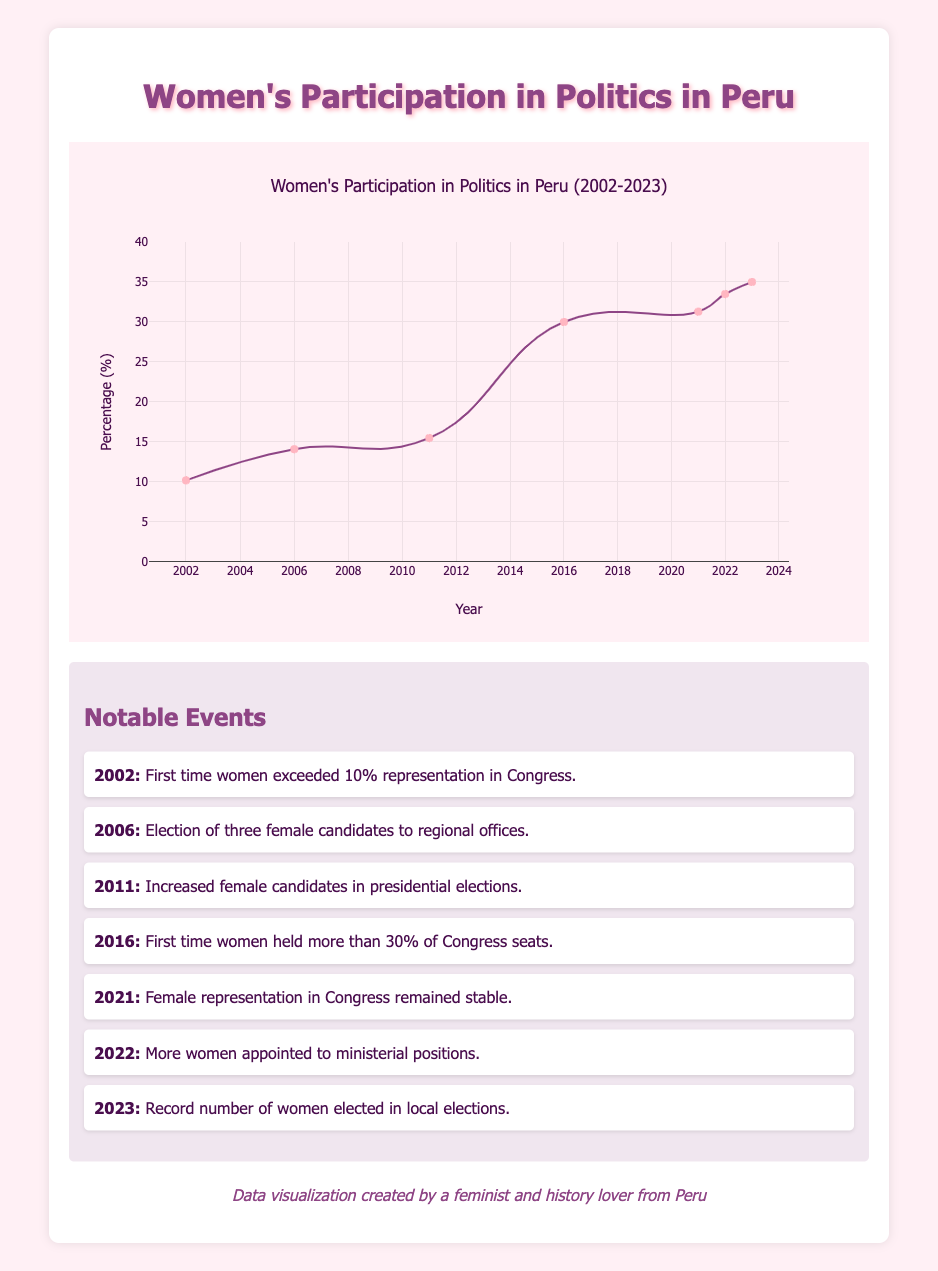What was the percentage of women's participation in politics in Peru in 2021? In the table, we can locate the entry for the year 2021, which indicates a participation percentage of 31.3% for that year.
Answer: 31.3% What notable event occurred in 2016 regarding women's representation? According to the notable event section, in 2016, women held more than 30% of Congress seats for the first time.
Answer: Women held more than 30% of Congress seats What is the average percentage of women's participation in politics from 2002 to 2023? To find the average, we first sum the percentages for each year: (10.2 + 14.1 + 15.5 + 30.0 + 31.3 + 33.5 + 35.0) = 139.6%. Then, we divide by the number of years, which is 7. Therefore, the average is 139.6 / 7 ≈ 19.94%.
Answer: 19.94% In which year did the percentage of women's participation in politics first exceed 30%? By reviewing the table, we can see that the first year where the percentage exceeded 30% was 2016, as it is the first year that shows a percentage of 30.0%.
Answer: 2016 Has the percentage of women's participation in politics been consistently increasing from 2002 to 2023? Examining the data points in the table from 2002 to 2023 shows that each succeeding year has a higher percentage than the previous one, indicating a consistent increase.
Answer: Yes 